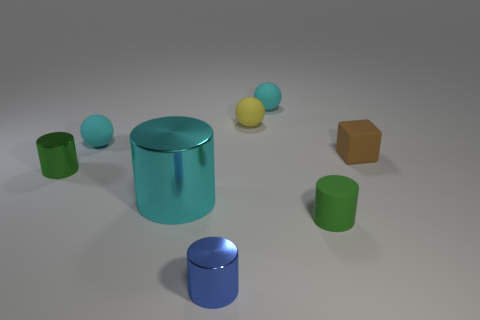Subtract all cyan spheres. How many spheres are left? 1 Subtract all tiny cyan matte spheres. How many spheres are left? 1 Add 2 cyan cylinders. How many objects exist? 10 Subtract 0 yellow blocks. How many objects are left? 8 Subtract all spheres. How many objects are left? 5 Subtract 1 balls. How many balls are left? 2 Subtract all gray spheres. Subtract all purple blocks. How many spheres are left? 3 Subtract all green balls. How many blue cylinders are left? 1 Subtract all small purple cylinders. Subtract all matte things. How many objects are left? 3 Add 6 shiny objects. How many shiny objects are left? 9 